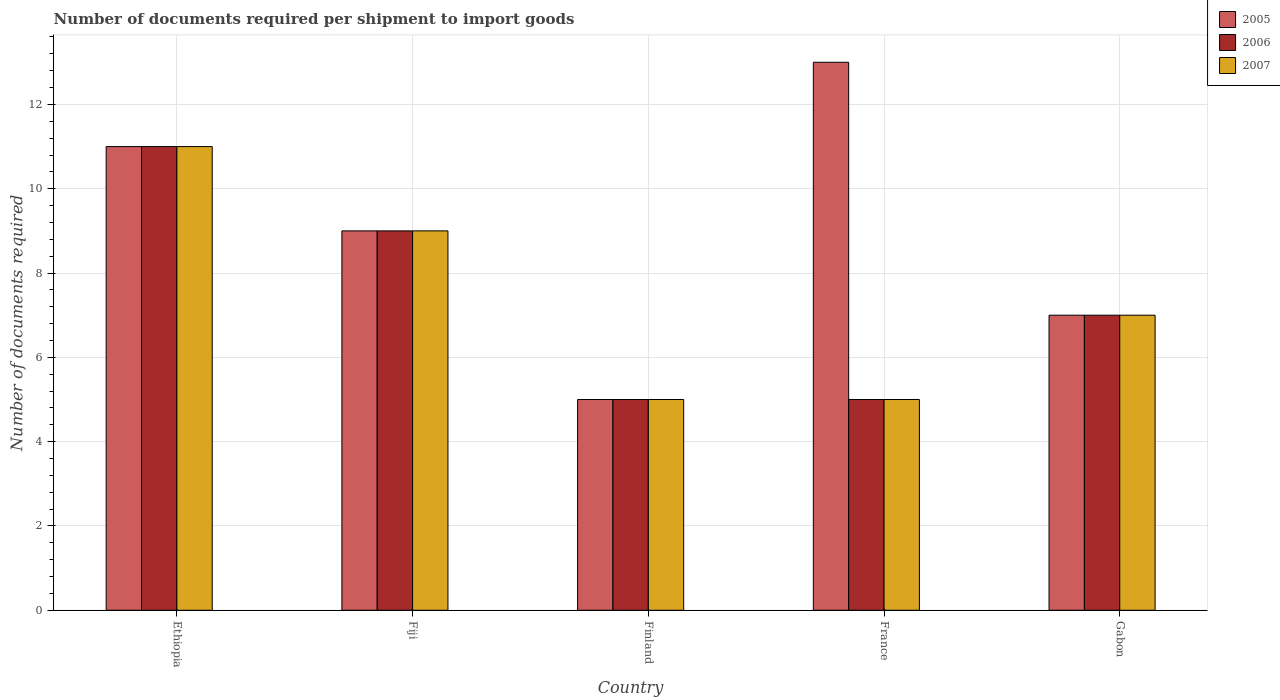How many groups of bars are there?
Provide a succinct answer. 5. Are the number of bars on each tick of the X-axis equal?
Keep it short and to the point. Yes. How many bars are there on the 3rd tick from the left?
Give a very brief answer. 3. How many bars are there on the 5th tick from the right?
Offer a terse response. 3. In how many cases, is the number of bars for a given country not equal to the number of legend labels?
Your response must be concise. 0. Across all countries, what is the minimum number of documents required per shipment to import goods in 2007?
Offer a very short reply. 5. In which country was the number of documents required per shipment to import goods in 2006 maximum?
Your response must be concise. Ethiopia. Is the number of documents required per shipment to import goods in 2005 in Ethiopia less than that in France?
Provide a succinct answer. Yes. Is the sum of the number of documents required per shipment to import goods in 2007 in Ethiopia and France greater than the maximum number of documents required per shipment to import goods in 2006 across all countries?
Offer a terse response. Yes. What does the 3rd bar from the right in Ethiopia represents?
Your answer should be very brief. 2005. Is it the case that in every country, the sum of the number of documents required per shipment to import goods in 2007 and number of documents required per shipment to import goods in 2005 is greater than the number of documents required per shipment to import goods in 2006?
Make the answer very short. Yes. What is the difference between two consecutive major ticks on the Y-axis?
Keep it short and to the point. 2. Does the graph contain grids?
Your answer should be very brief. Yes. What is the title of the graph?
Offer a very short reply. Number of documents required per shipment to import goods. Does "2010" appear as one of the legend labels in the graph?
Your answer should be compact. No. What is the label or title of the Y-axis?
Your response must be concise. Number of documents required. What is the Number of documents required in 2005 in Fiji?
Provide a short and direct response. 9. What is the Number of documents required in 2006 in Fiji?
Your answer should be very brief. 9. What is the Number of documents required in 2006 in Finland?
Ensure brevity in your answer.  5. Across all countries, what is the maximum Number of documents required of 2005?
Make the answer very short. 13. Across all countries, what is the maximum Number of documents required in 2006?
Provide a succinct answer. 11. Across all countries, what is the maximum Number of documents required of 2007?
Give a very brief answer. 11. Across all countries, what is the minimum Number of documents required of 2006?
Give a very brief answer. 5. Across all countries, what is the minimum Number of documents required of 2007?
Provide a succinct answer. 5. What is the total Number of documents required of 2006 in the graph?
Offer a very short reply. 37. What is the total Number of documents required of 2007 in the graph?
Your response must be concise. 37. What is the difference between the Number of documents required of 2006 in Ethiopia and that in Fiji?
Your response must be concise. 2. What is the difference between the Number of documents required in 2005 in Ethiopia and that in Finland?
Keep it short and to the point. 6. What is the difference between the Number of documents required of 2007 in Ethiopia and that in Finland?
Offer a terse response. 6. What is the difference between the Number of documents required of 2005 in Ethiopia and that in France?
Your answer should be very brief. -2. What is the difference between the Number of documents required in 2007 in Ethiopia and that in France?
Keep it short and to the point. 6. What is the difference between the Number of documents required of 2005 in Ethiopia and that in Gabon?
Offer a terse response. 4. What is the difference between the Number of documents required of 2006 in Ethiopia and that in Gabon?
Make the answer very short. 4. What is the difference between the Number of documents required in 2006 in Fiji and that in Finland?
Give a very brief answer. 4. What is the difference between the Number of documents required of 2006 in Fiji and that in France?
Your response must be concise. 4. What is the difference between the Number of documents required in 2007 in Fiji and that in France?
Make the answer very short. 4. What is the difference between the Number of documents required of 2007 in Fiji and that in Gabon?
Keep it short and to the point. 2. What is the difference between the Number of documents required of 2005 in Finland and that in France?
Ensure brevity in your answer.  -8. What is the difference between the Number of documents required of 2006 in Finland and that in France?
Offer a very short reply. 0. What is the difference between the Number of documents required of 2006 in Finland and that in Gabon?
Keep it short and to the point. -2. What is the difference between the Number of documents required in 2006 in France and that in Gabon?
Keep it short and to the point. -2. What is the difference between the Number of documents required of 2005 in Ethiopia and the Number of documents required of 2006 in Fiji?
Your response must be concise. 2. What is the difference between the Number of documents required in 2006 in Ethiopia and the Number of documents required in 2007 in Fiji?
Offer a very short reply. 2. What is the difference between the Number of documents required in 2005 in Ethiopia and the Number of documents required in 2006 in Finland?
Ensure brevity in your answer.  6. What is the difference between the Number of documents required in 2005 in Ethiopia and the Number of documents required in 2007 in Finland?
Ensure brevity in your answer.  6. What is the difference between the Number of documents required of 2006 in Ethiopia and the Number of documents required of 2007 in Finland?
Offer a very short reply. 6. What is the difference between the Number of documents required in 2005 in Ethiopia and the Number of documents required in 2006 in France?
Provide a short and direct response. 6. What is the difference between the Number of documents required in 2005 in Ethiopia and the Number of documents required in 2007 in France?
Offer a very short reply. 6. What is the difference between the Number of documents required of 2006 in Ethiopia and the Number of documents required of 2007 in France?
Your answer should be compact. 6. What is the difference between the Number of documents required of 2005 in Ethiopia and the Number of documents required of 2006 in Gabon?
Your response must be concise. 4. What is the difference between the Number of documents required of 2005 in Ethiopia and the Number of documents required of 2007 in Gabon?
Make the answer very short. 4. What is the difference between the Number of documents required of 2006 in Ethiopia and the Number of documents required of 2007 in Gabon?
Your answer should be very brief. 4. What is the difference between the Number of documents required in 2005 in Fiji and the Number of documents required in 2007 in Finland?
Offer a terse response. 4. What is the difference between the Number of documents required in 2005 in Fiji and the Number of documents required in 2006 in France?
Offer a terse response. 4. What is the difference between the Number of documents required of 2005 in Fiji and the Number of documents required of 2007 in France?
Offer a very short reply. 4. What is the difference between the Number of documents required of 2005 in Fiji and the Number of documents required of 2007 in Gabon?
Offer a very short reply. 2. What is the difference between the Number of documents required in 2006 in Fiji and the Number of documents required in 2007 in Gabon?
Your answer should be very brief. 2. What is the difference between the Number of documents required of 2005 in Finland and the Number of documents required of 2007 in France?
Keep it short and to the point. 0. What is the difference between the Number of documents required of 2006 in Finland and the Number of documents required of 2007 in France?
Give a very brief answer. 0. What is the difference between the Number of documents required in 2006 in Finland and the Number of documents required in 2007 in Gabon?
Offer a terse response. -2. What is the difference between the Number of documents required of 2005 in France and the Number of documents required of 2007 in Gabon?
Give a very brief answer. 6. What is the average Number of documents required of 2006 per country?
Your answer should be compact. 7.4. What is the average Number of documents required in 2007 per country?
Keep it short and to the point. 7.4. What is the difference between the Number of documents required of 2005 and Number of documents required of 2006 in Ethiopia?
Give a very brief answer. 0. What is the difference between the Number of documents required in 2006 and Number of documents required in 2007 in Ethiopia?
Offer a terse response. 0. What is the difference between the Number of documents required of 2005 and Number of documents required of 2006 in Fiji?
Your answer should be compact. 0. What is the difference between the Number of documents required of 2005 and Number of documents required of 2006 in Finland?
Make the answer very short. 0. What is the difference between the Number of documents required in 2006 and Number of documents required in 2007 in Finland?
Offer a very short reply. 0. What is the difference between the Number of documents required in 2005 and Number of documents required in 2007 in France?
Give a very brief answer. 8. What is the ratio of the Number of documents required of 2005 in Ethiopia to that in Fiji?
Provide a succinct answer. 1.22. What is the ratio of the Number of documents required of 2006 in Ethiopia to that in Fiji?
Ensure brevity in your answer.  1.22. What is the ratio of the Number of documents required in 2007 in Ethiopia to that in Fiji?
Offer a terse response. 1.22. What is the ratio of the Number of documents required of 2005 in Ethiopia to that in France?
Offer a very short reply. 0.85. What is the ratio of the Number of documents required of 2007 in Ethiopia to that in France?
Offer a very short reply. 2.2. What is the ratio of the Number of documents required of 2005 in Ethiopia to that in Gabon?
Keep it short and to the point. 1.57. What is the ratio of the Number of documents required in 2006 in Ethiopia to that in Gabon?
Offer a very short reply. 1.57. What is the ratio of the Number of documents required of 2007 in Ethiopia to that in Gabon?
Your answer should be very brief. 1.57. What is the ratio of the Number of documents required in 2007 in Fiji to that in Finland?
Your response must be concise. 1.8. What is the ratio of the Number of documents required in 2005 in Fiji to that in France?
Your answer should be very brief. 0.69. What is the ratio of the Number of documents required in 2007 in Fiji to that in France?
Give a very brief answer. 1.8. What is the ratio of the Number of documents required of 2005 in Fiji to that in Gabon?
Provide a succinct answer. 1.29. What is the ratio of the Number of documents required of 2007 in Fiji to that in Gabon?
Offer a terse response. 1.29. What is the ratio of the Number of documents required of 2005 in Finland to that in France?
Provide a succinct answer. 0.38. What is the ratio of the Number of documents required in 2005 in Finland to that in Gabon?
Offer a very short reply. 0.71. What is the ratio of the Number of documents required in 2005 in France to that in Gabon?
Keep it short and to the point. 1.86. What is the difference between the highest and the lowest Number of documents required of 2006?
Your answer should be compact. 6. 